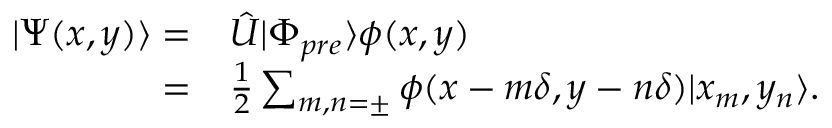Convert formula to latex. <formula><loc_0><loc_0><loc_500><loc_500>\begin{array} { r l } { | \Psi ( x , y ) \rangle = } & \hat { U } | \Phi _ { p r e } \rangle \phi ( x , y ) } \\ { = } & \frac { 1 } { 2 } \sum _ { m , n = \pm } \phi ( x - m \delta , y - n \delta ) | x _ { m } , y _ { n } \rangle . } \end{array}</formula> 